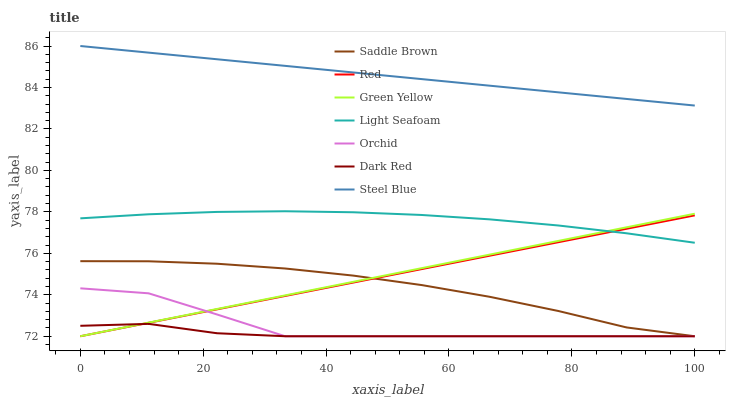Does Dark Red have the minimum area under the curve?
Answer yes or no. Yes. Does Steel Blue have the maximum area under the curve?
Answer yes or no. Yes. Does Steel Blue have the minimum area under the curve?
Answer yes or no. No. Does Dark Red have the maximum area under the curve?
Answer yes or no. No. Is Steel Blue the smoothest?
Answer yes or no. Yes. Is Orchid the roughest?
Answer yes or no. Yes. Is Dark Red the smoothest?
Answer yes or no. No. Is Dark Red the roughest?
Answer yes or no. No. Does Green Yellow have the lowest value?
Answer yes or no. Yes. Does Steel Blue have the lowest value?
Answer yes or no. No. Does Steel Blue have the highest value?
Answer yes or no. Yes. Does Dark Red have the highest value?
Answer yes or no. No. Is Orchid less than Steel Blue?
Answer yes or no. Yes. Is Steel Blue greater than Orchid?
Answer yes or no. Yes. Does Green Yellow intersect Saddle Brown?
Answer yes or no. Yes. Is Green Yellow less than Saddle Brown?
Answer yes or no. No. Is Green Yellow greater than Saddle Brown?
Answer yes or no. No. Does Orchid intersect Steel Blue?
Answer yes or no. No. 